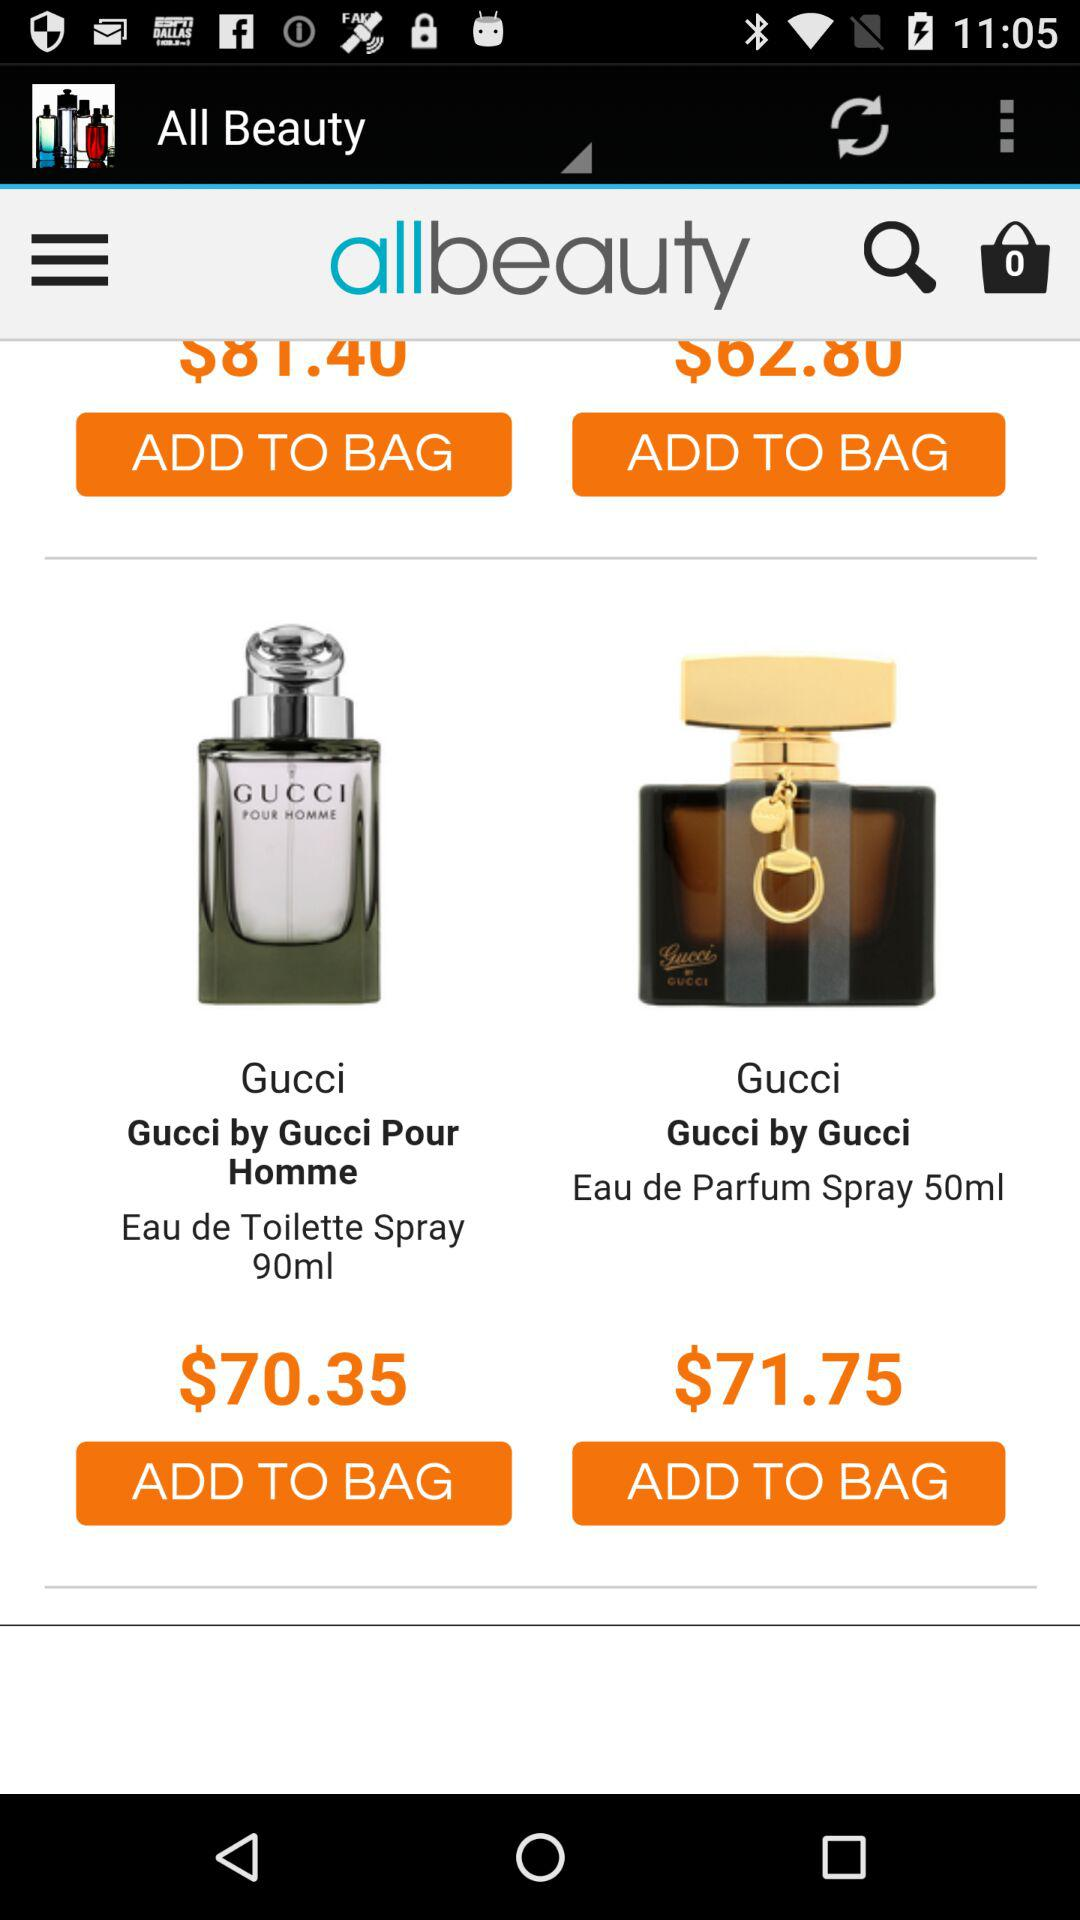How much is the total?
When the provided information is insufficient, respond with <no answer>. <no answer> 